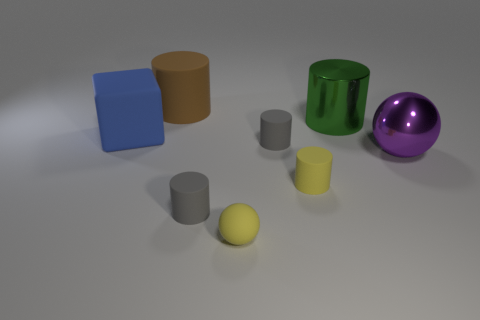The small sphere has what color? yellow 